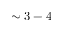Convert formula to latex. <formula><loc_0><loc_0><loc_500><loc_500>\sim 3 - 4</formula> 